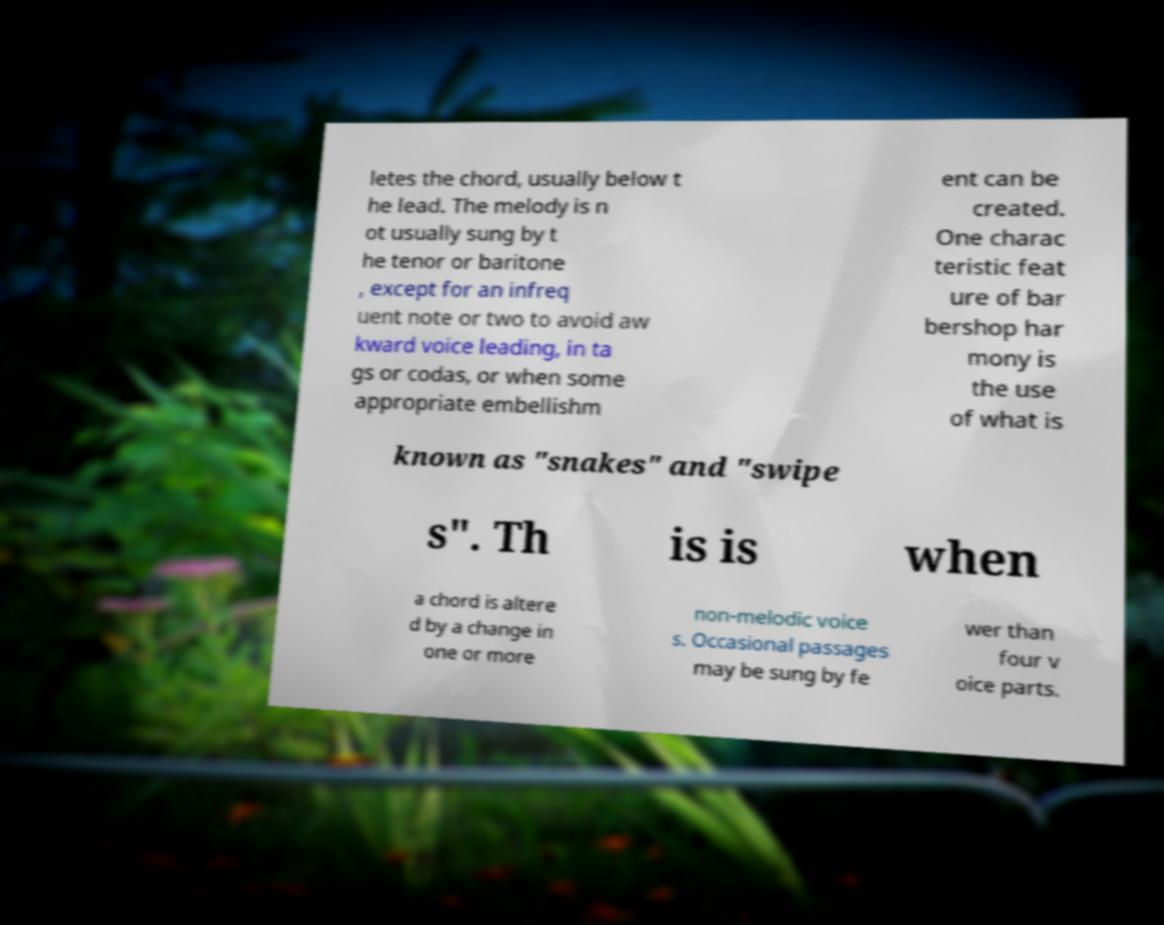Can you accurately transcribe the text from the provided image for me? letes the chord, usually below t he lead. The melody is n ot usually sung by t he tenor or baritone , except for an infreq uent note or two to avoid aw kward voice leading, in ta gs or codas, or when some appropriate embellishm ent can be created. One charac teristic feat ure of bar bershop har mony is the use of what is known as "snakes" and "swipe s". Th is is when a chord is altere d by a change in one or more non-melodic voice s. Occasional passages may be sung by fe wer than four v oice parts. 